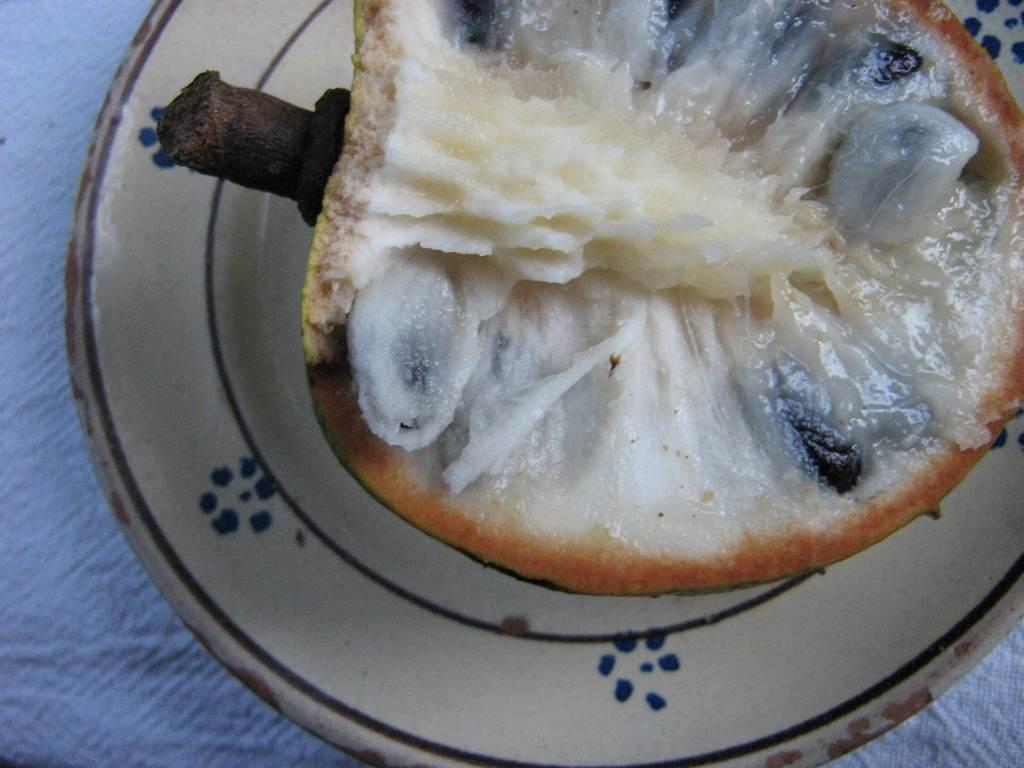What type of food is present in the image? There is a fruit with seeds in the image. How is the fruit displayed in the image? The fruit is placed on a plate. What type of structure can be seen supporting the fruit in the image? There is no structure supporting the fruit in the image; it is simply placed on a plate. How are the seeds of the fruit sorted in the image? The image does not show the seeds being sorted; it only shows the fruit on a plate. 